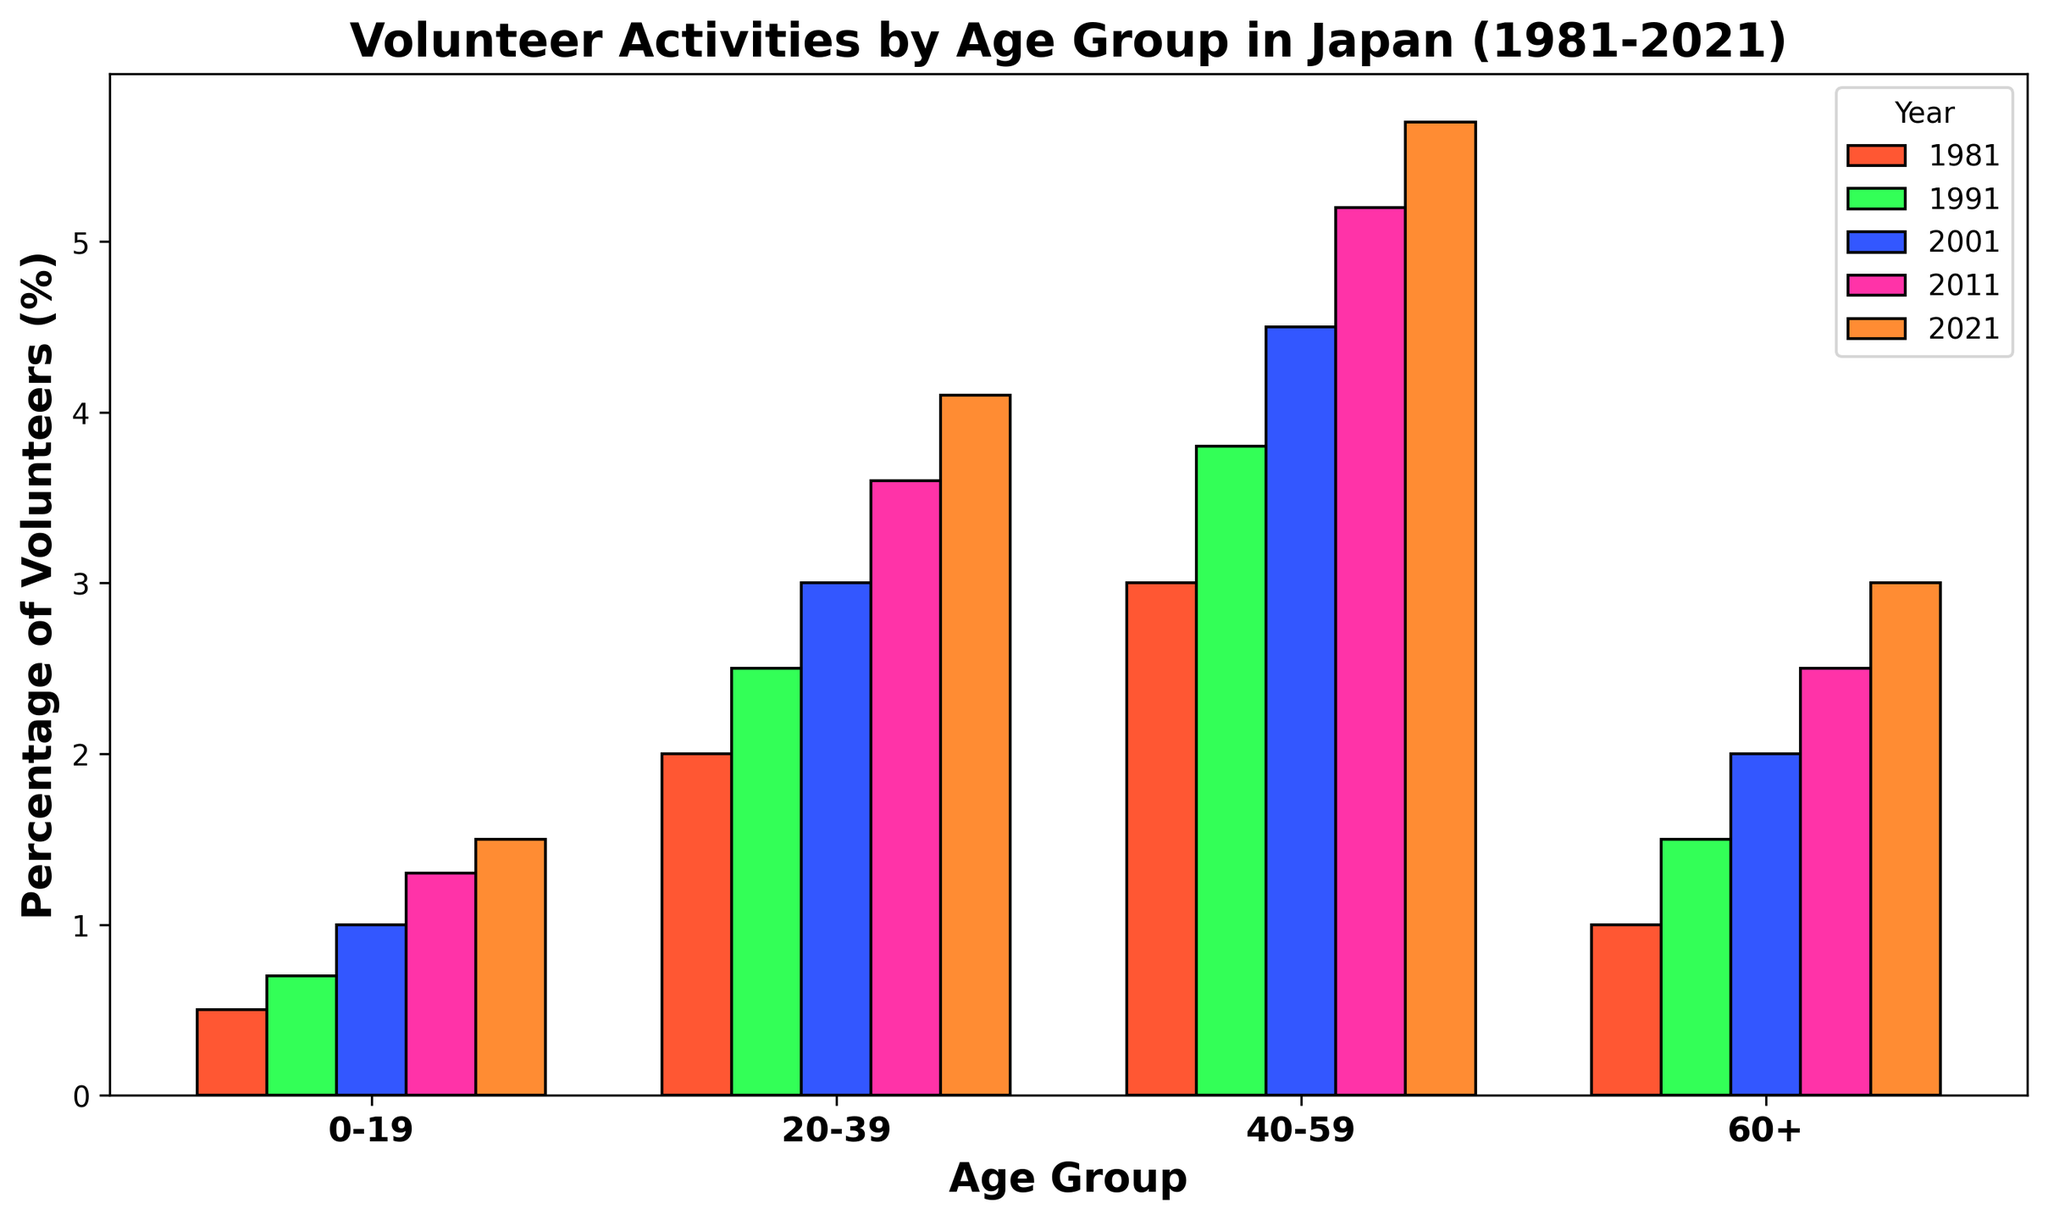What is the trend of volunteer activities for the age group 0-19 from 1981 to 2021? Each bar for the age group 0-19 shows a consistent increase over the years. The bars height increases as follows: 1981 (0.5%), 1991 (0.7%), 2001 (1.0%), 2011 (1.3%), 2021 (1.5%).
Answer: Increasing trend Which age group had the highest increase in volunteering activities between 1981 and 2021? Subtract the 1981 percentage from the 2021 percentage for each age group:
0-19: 1.5 - 0.5 = 1.0
20-39: 4.1 - 2.0 = 2.1
40-59: 5.7 - 3.0 = 2.7
60+: 3.0 - 1.0 = 2.0.
The group 40-59 had the highest increase (2.7%).
Answer: 40-59 Compare the volunteer activity percentage of the age group 20-39 in 2001 and 2021. Which year had a higher percentage? Look at the heights of the bars for the age group 20-39 in the years 2001 (3.0%) and 2021 (4.1%). The 2021 bar is higher.
Answer: 2021 What is the overall average percentage of volunteer activities for the age group 60+ from 1981 to 2021? Add percentages for each year for 60+ and divide by the number of years: (1.0 + 1.5 + 2.0 + 2.5 + 3.0)/5 = 2.0.
Answer: 2.0% Which year had the lowest volunteer activity percentage for the age group 60+? Compare the bar heights for 60+ across all years. The lowest is in 1981 (1.0%).
Answer: 1981 What is the difference in volunteer activities between the age groups 0-19 and 40-59 in 2021? Subtract the percentage for 0-19 (1.5%) from the percentage for 40-59 (5.7%):
5.7% - 1.5% = 4.2%.
Answer: 4.2% Which age group has the largest volunteer activity in 2011? Compare the heights of the bars for all age groups in 2011. The tallest bar is for 40-59 (5.2%).
Answer: 40-59 How many age groups experience a consistent increase in volunteer activities from 1981 to 2021? Check each age group bar across the years for a consistent increase: 
0-19: increasing,
20-39: increasing,
40-59: increasing,
60+: increasing. 
All 4 groups show a consistent increase.
Answer: 4 